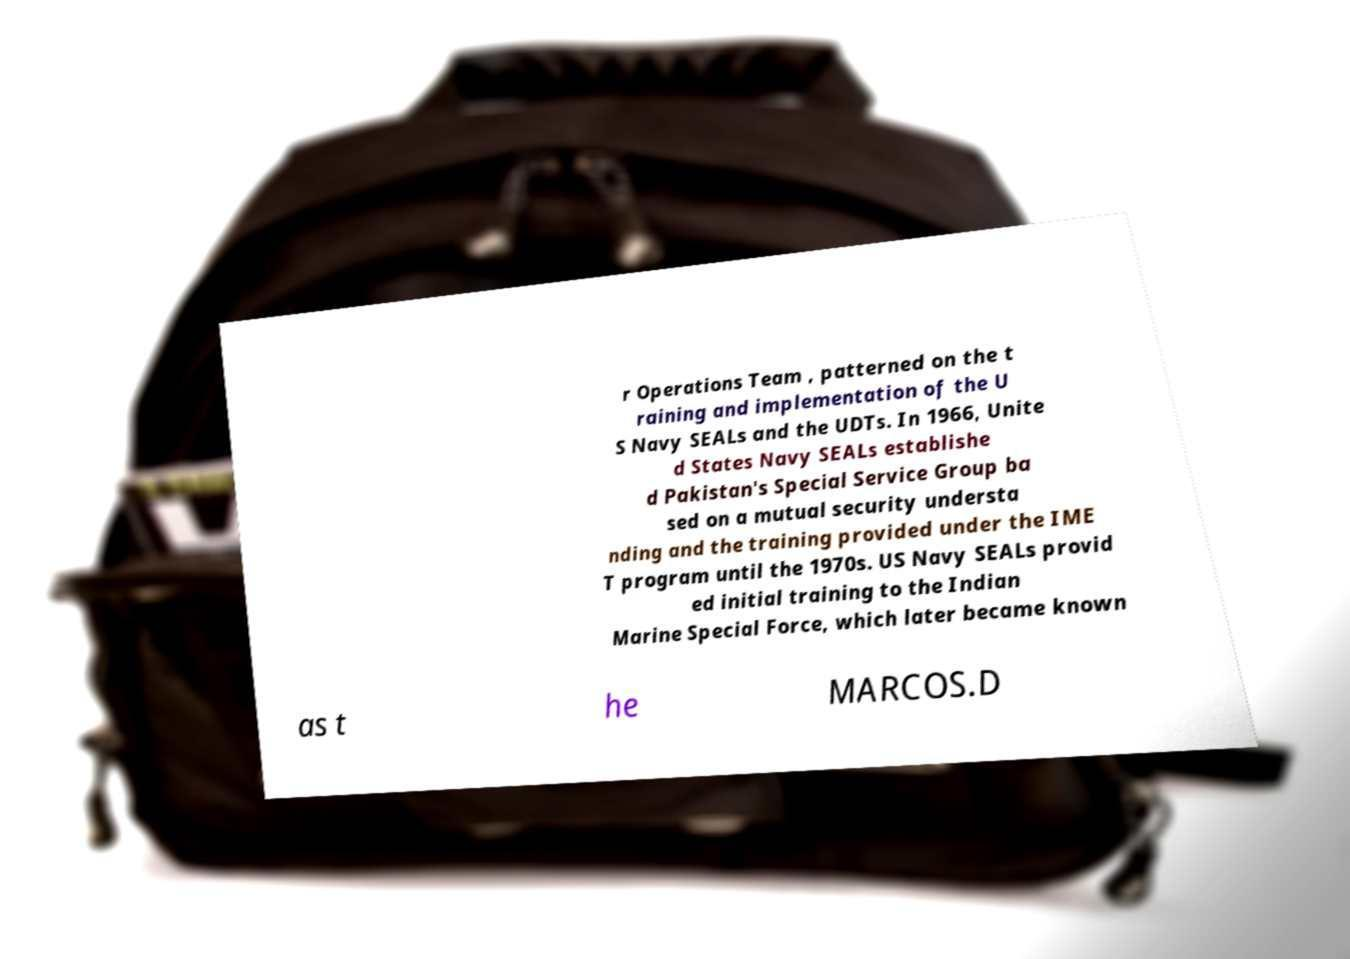I need the written content from this picture converted into text. Can you do that? r Operations Team , patterned on the t raining and implementation of the U S Navy SEALs and the UDTs. In 1966, Unite d States Navy SEALs establishe d Pakistan's Special Service Group ba sed on a mutual security understa nding and the training provided under the IME T program until the 1970s. US Navy SEALs provid ed initial training to the Indian Marine Special Force, which later became known as t he MARCOS.D 